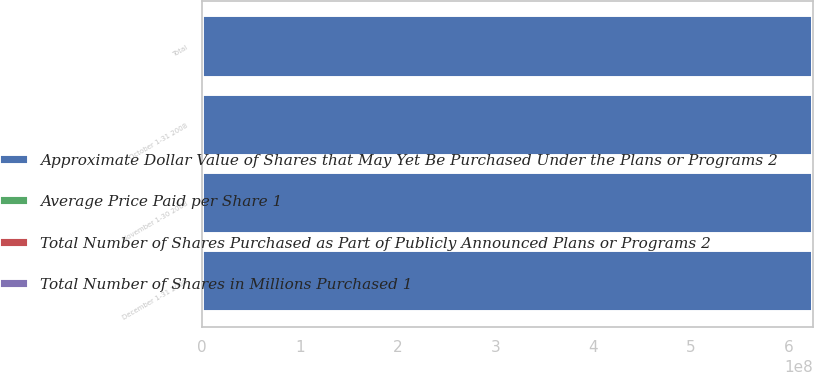Convert chart. <chart><loc_0><loc_0><loc_500><loc_500><stacked_bar_chart><ecel><fcel>October 1-31 2008<fcel>November 1-30 2008<fcel>December 1-31 2008<fcel>Total<nl><fcel>Total Number of Shares in Millions Purchased 1<fcel>1280<fcel>113<fcel>2547<fcel>3940<nl><fcel>Total Number of Shares Purchased as Part of Publicly Announced Plans or Programs 2<fcel>14.56<fcel>10.41<fcel>8.67<fcel>10.63<nl><fcel>Average Price Paid per Share 1<fcel>0<fcel>0<fcel>0<fcel>0<nl><fcel>Approximate Dollar Value of Shares that May Yet Be Purchased Under the Plans or Programs 2<fcel>6.25037e+08<fcel>6.25037e+08<fcel>6.25037e+08<fcel>6.25037e+08<nl></chart> 